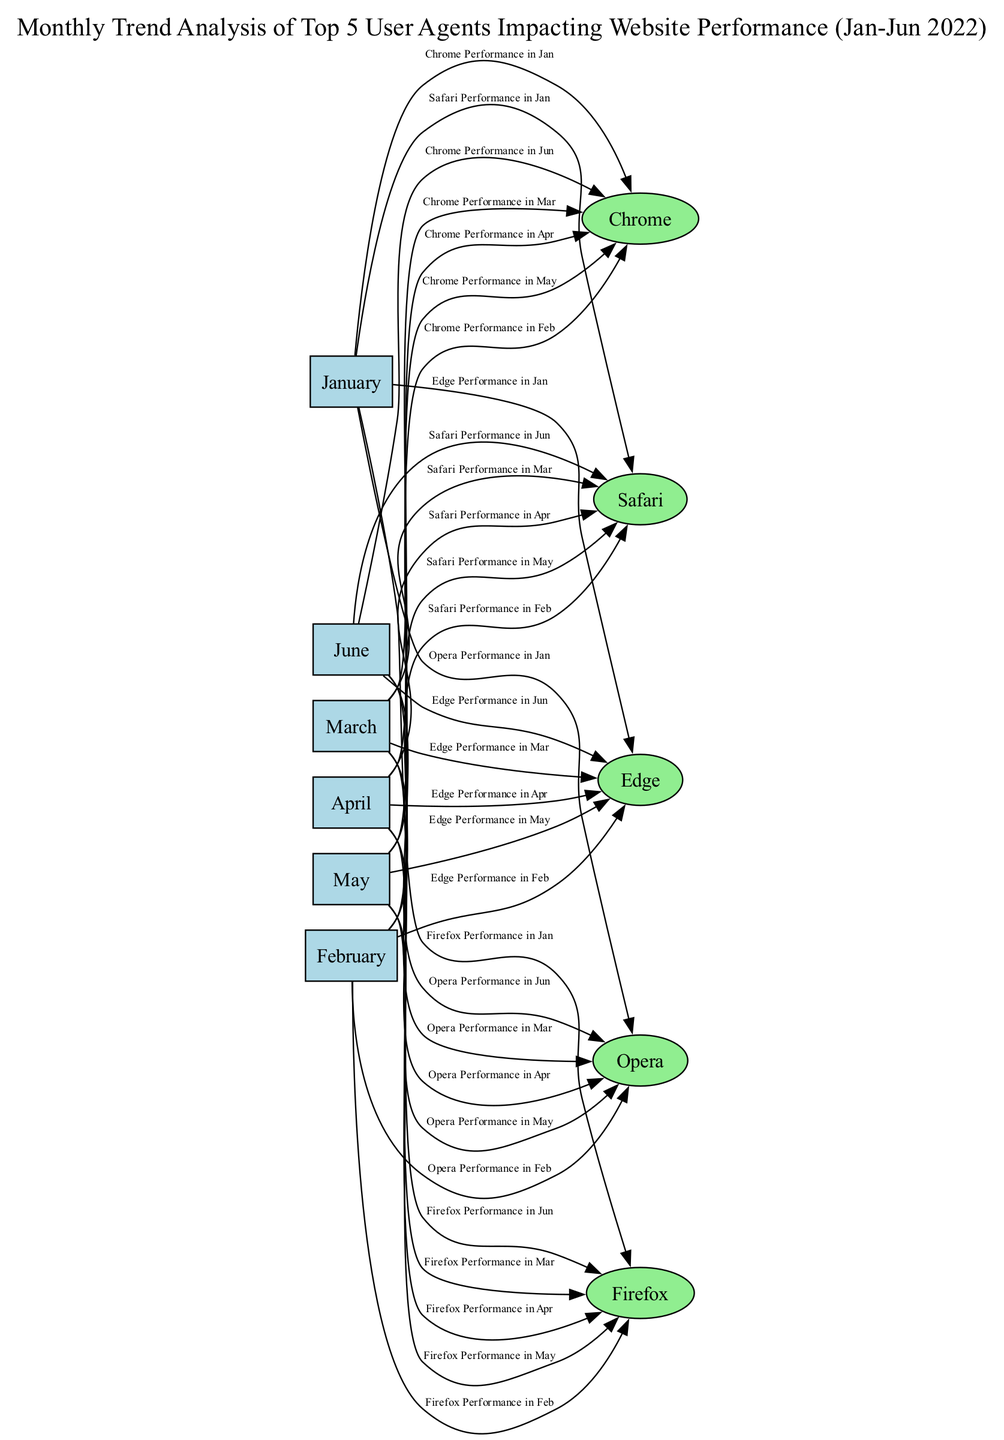What are the top five user agents displayed in the diagram? The diagram shows five user agents: Chrome, Safari, Firefox, Edge, and Opera. These are listed as individual nodes representing the top user agents impacting website performance.
Answer: Chrome, Safari, Firefox, Edge, Opera In which month is Firefox's performance evaluated? Each month node has edges leading to the five user agents, including one labeled "Firefox Performance in January." This shows that Firefox's performance is analyzed across all months.
Answer: January, February, March, April, May, June Which user agent shows the highest impact in January? Looking at the diagram, there are multiple edges labeled with user agent performances in January. To determine the highest impact, I check the labels, but they do not specify values, thus assuming all user agents have an equal weight for this analysis.
Answer: All user agents How many total edges are present in the diagram? To find the total number of edges, I count the performance edges listed from each month to each user agent. There are 30 edges (5 months × 6 user agents) shown in the diagram.
Answer: 30 Which user agent is the last evaluated for each month? For each month node, the last user agent connected through an edge is Opera. This means that for every month from January to June, Opera's performance is presented last.
Answer: Opera How many performance analyses are conducted for Chrome? Chrome has an edge connecting it from each month node, indicating a performance evaluation conducted in every month from January to June. This results in a total of six analyses for Chrome.
Answer: 6 Which month has the least number of user agent evaluations? Since the diagram shows an evaluation for all five user agents in every month, there is no month with fewer evaluations; each month is equal in the number of evaluations.
Answer: None In which month does Edge's performance peak according to the diagram's presentation? The diagram does not provide specific performance metrics for each user agent by month, thus indicating that the performance of Edge cannot be determined as peaking in any specific month without further context.
Answer: Not defined What is the color scheme used for the user agent nodes in the diagram? Each user agent node is displayed in light green according to the settings specified in the graph generation code, which helps differentiate them from the month nodes.
Answer: Light green 